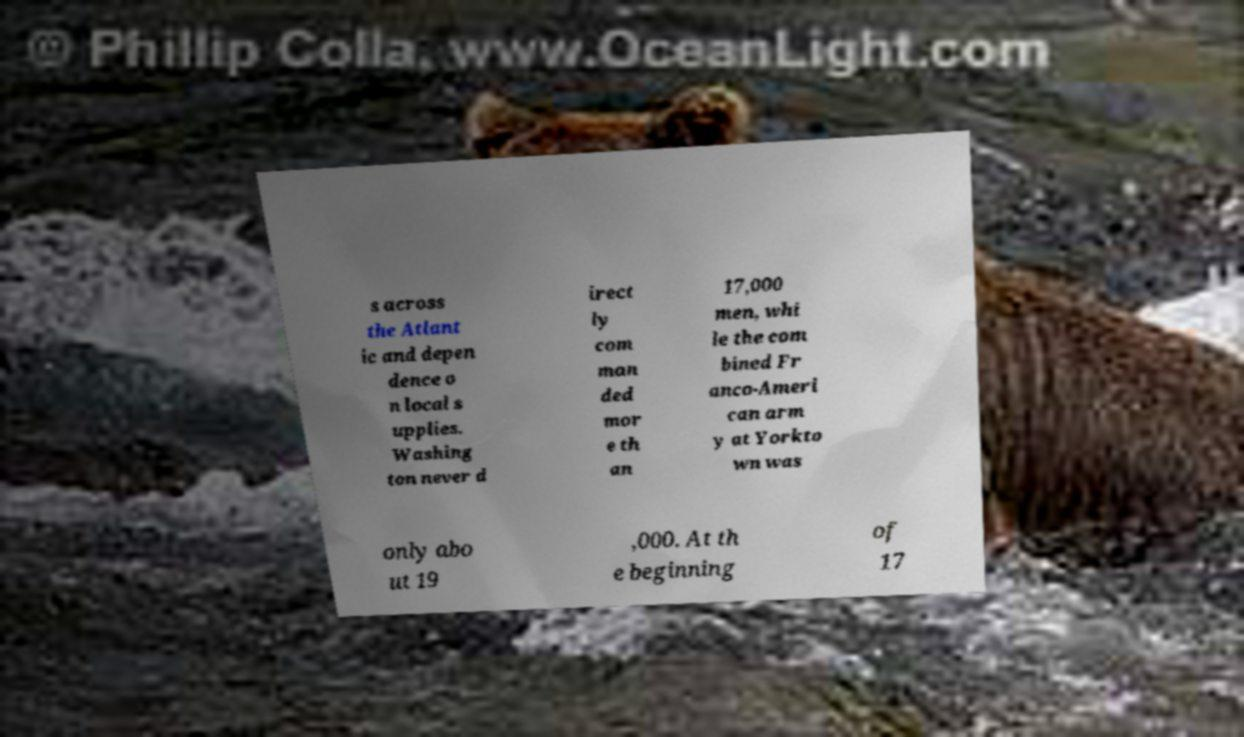Can you read and provide the text displayed in the image?This photo seems to have some interesting text. Can you extract and type it out for me? s across the Atlant ic and depen dence o n local s upplies. Washing ton never d irect ly com man ded mor e th an 17,000 men, whi le the com bined Fr anco-Ameri can arm y at Yorkto wn was only abo ut 19 ,000. At th e beginning of 17 